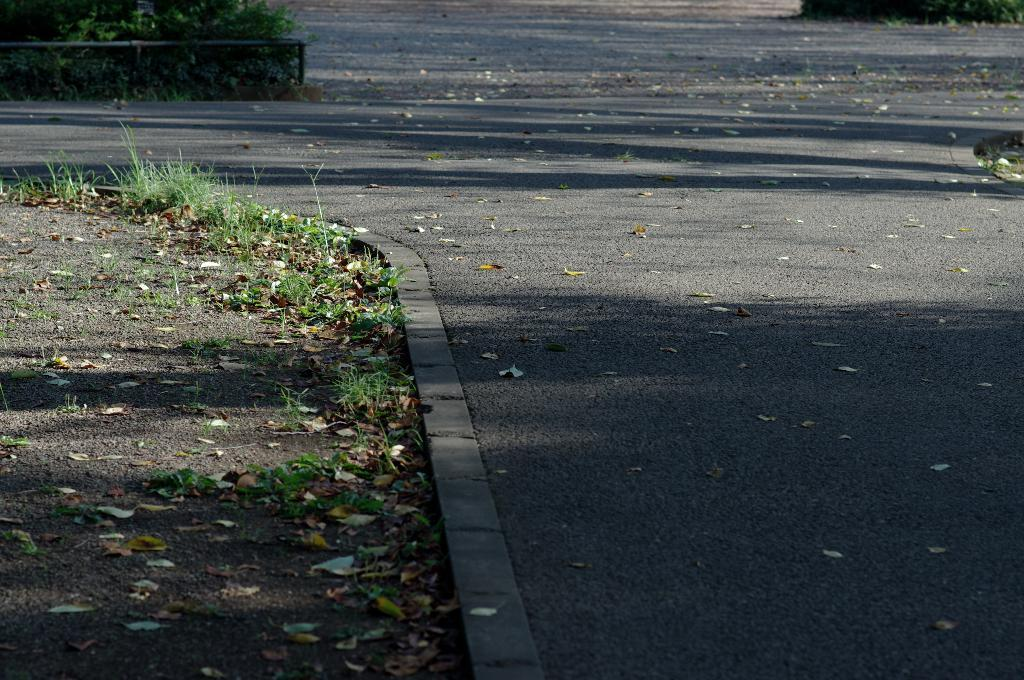What type of surface can be seen in the image? There is a road in the image. What structure is visible alongside the road? There is a fence in the image. What type of vegetation is present in the image? There are plants and grass in the image. What additional detail can be observed in the image? Dried leaves are present in the image. How many toys are scattered on the grass in the image? There are no toys present in the image; it features a road, a fence, plants, grass, and dried leaves. Can you spot any lizards crawling on the fence in the image? There are no lizards visible in the image; it only shows a road, a fence, plants, grass, and dried leaves. 